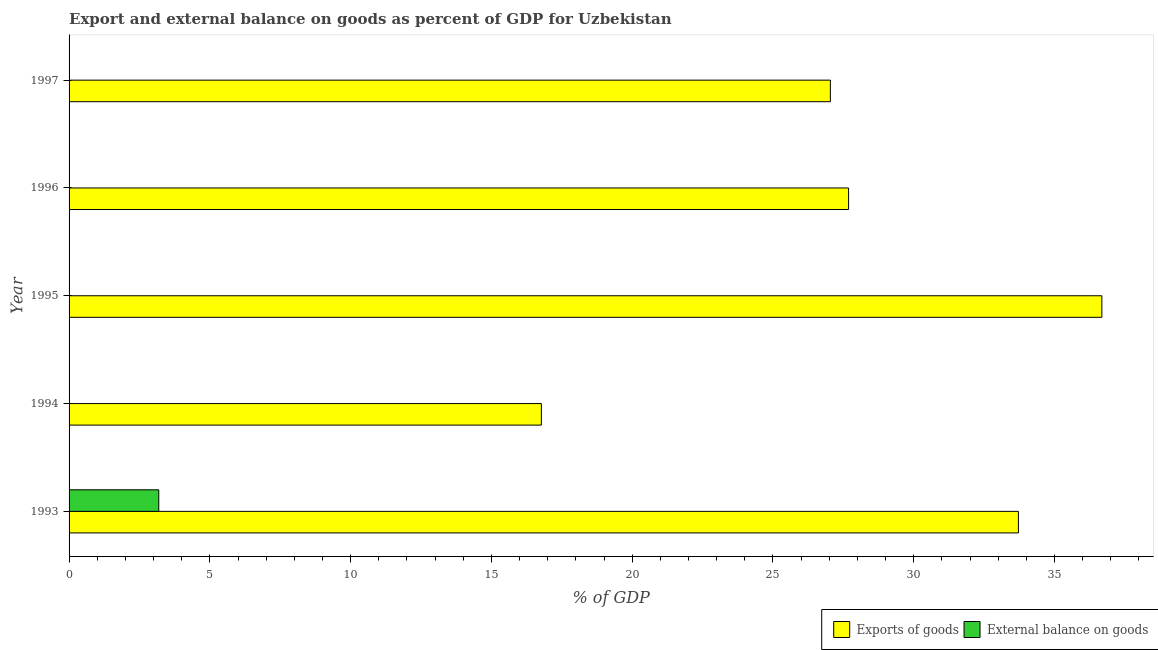How many different coloured bars are there?
Ensure brevity in your answer.  2. Are the number of bars per tick equal to the number of legend labels?
Make the answer very short. No. In how many cases, is the number of bars for a given year not equal to the number of legend labels?
Give a very brief answer. 4. Across all years, what is the maximum external balance on goods as percentage of gdp?
Give a very brief answer. 3.19. Across all years, what is the minimum external balance on goods as percentage of gdp?
Give a very brief answer. 0. What is the total external balance on goods as percentage of gdp in the graph?
Your answer should be compact. 3.19. What is the difference between the export of goods as percentage of gdp in 1995 and that in 1997?
Give a very brief answer. 9.64. What is the difference between the external balance on goods as percentage of gdp in 1995 and the export of goods as percentage of gdp in 1993?
Offer a terse response. -33.72. What is the average external balance on goods as percentage of gdp per year?
Keep it short and to the point. 0.64. In the year 1993, what is the difference between the external balance on goods as percentage of gdp and export of goods as percentage of gdp?
Offer a terse response. -30.53. What is the ratio of the export of goods as percentage of gdp in 1995 to that in 1997?
Give a very brief answer. 1.36. What is the difference between the highest and the second highest export of goods as percentage of gdp?
Your answer should be compact. 2.96. What is the difference between the highest and the lowest external balance on goods as percentage of gdp?
Provide a short and direct response. 3.19. Is the sum of the export of goods as percentage of gdp in 1996 and 1997 greater than the maximum external balance on goods as percentage of gdp across all years?
Your answer should be very brief. Yes. Are all the bars in the graph horizontal?
Ensure brevity in your answer.  Yes. What is the difference between two consecutive major ticks on the X-axis?
Your answer should be very brief. 5. Are the values on the major ticks of X-axis written in scientific E-notation?
Provide a short and direct response. No. Does the graph contain grids?
Provide a succinct answer. No. Where does the legend appear in the graph?
Your answer should be compact. Bottom right. How are the legend labels stacked?
Offer a terse response. Horizontal. What is the title of the graph?
Provide a short and direct response. Export and external balance on goods as percent of GDP for Uzbekistan. Does "Non-solid fuel" appear as one of the legend labels in the graph?
Your answer should be very brief. No. What is the label or title of the X-axis?
Ensure brevity in your answer.  % of GDP. What is the label or title of the Y-axis?
Ensure brevity in your answer.  Year. What is the % of GDP of Exports of goods in 1993?
Your response must be concise. 33.72. What is the % of GDP in External balance on goods in 1993?
Make the answer very short. 3.19. What is the % of GDP of Exports of goods in 1994?
Your answer should be very brief. 16.78. What is the % of GDP in Exports of goods in 1995?
Your response must be concise. 36.68. What is the % of GDP of External balance on goods in 1995?
Your response must be concise. 0. What is the % of GDP of Exports of goods in 1996?
Provide a short and direct response. 27.69. What is the % of GDP in External balance on goods in 1996?
Your response must be concise. 0. What is the % of GDP of Exports of goods in 1997?
Provide a short and direct response. 27.04. Across all years, what is the maximum % of GDP of Exports of goods?
Ensure brevity in your answer.  36.68. Across all years, what is the maximum % of GDP of External balance on goods?
Offer a very short reply. 3.19. Across all years, what is the minimum % of GDP in Exports of goods?
Keep it short and to the point. 16.78. What is the total % of GDP of Exports of goods in the graph?
Keep it short and to the point. 141.91. What is the total % of GDP in External balance on goods in the graph?
Provide a short and direct response. 3.19. What is the difference between the % of GDP of Exports of goods in 1993 and that in 1994?
Give a very brief answer. 16.94. What is the difference between the % of GDP of Exports of goods in 1993 and that in 1995?
Provide a short and direct response. -2.96. What is the difference between the % of GDP of Exports of goods in 1993 and that in 1996?
Your answer should be very brief. 6.03. What is the difference between the % of GDP in Exports of goods in 1993 and that in 1997?
Your response must be concise. 6.68. What is the difference between the % of GDP in Exports of goods in 1994 and that in 1995?
Provide a short and direct response. -19.91. What is the difference between the % of GDP in Exports of goods in 1994 and that in 1996?
Make the answer very short. -10.91. What is the difference between the % of GDP in Exports of goods in 1994 and that in 1997?
Offer a very short reply. -10.26. What is the difference between the % of GDP in Exports of goods in 1995 and that in 1996?
Provide a short and direct response. 9. What is the difference between the % of GDP of Exports of goods in 1995 and that in 1997?
Keep it short and to the point. 9.64. What is the difference between the % of GDP in Exports of goods in 1996 and that in 1997?
Keep it short and to the point. 0.65. What is the average % of GDP of Exports of goods per year?
Keep it short and to the point. 28.38. What is the average % of GDP in External balance on goods per year?
Give a very brief answer. 0.64. In the year 1993, what is the difference between the % of GDP of Exports of goods and % of GDP of External balance on goods?
Keep it short and to the point. 30.53. What is the ratio of the % of GDP in Exports of goods in 1993 to that in 1994?
Your answer should be compact. 2.01. What is the ratio of the % of GDP in Exports of goods in 1993 to that in 1995?
Offer a terse response. 0.92. What is the ratio of the % of GDP of Exports of goods in 1993 to that in 1996?
Keep it short and to the point. 1.22. What is the ratio of the % of GDP in Exports of goods in 1993 to that in 1997?
Make the answer very short. 1.25. What is the ratio of the % of GDP of Exports of goods in 1994 to that in 1995?
Make the answer very short. 0.46. What is the ratio of the % of GDP of Exports of goods in 1994 to that in 1996?
Make the answer very short. 0.61. What is the ratio of the % of GDP of Exports of goods in 1994 to that in 1997?
Ensure brevity in your answer.  0.62. What is the ratio of the % of GDP of Exports of goods in 1995 to that in 1996?
Give a very brief answer. 1.32. What is the ratio of the % of GDP of Exports of goods in 1995 to that in 1997?
Ensure brevity in your answer.  1.36. What is the ratio of the % of GDP in Exports of goods in 1996 to that in 1997?
Keep it short and to the point. 1.02. What is the difference between the highest and the second highest % of GDP of Exports of goods?
Ensure brevity in your answer.  2.96. What is the difference between the highest and the lowest % of GDP of Exports of goods?
Make the answer very short. 19.91. What is the difference between the highest and the lowest % of GDP of External balance on goods?
Provide a succinct answer. 3.19. 